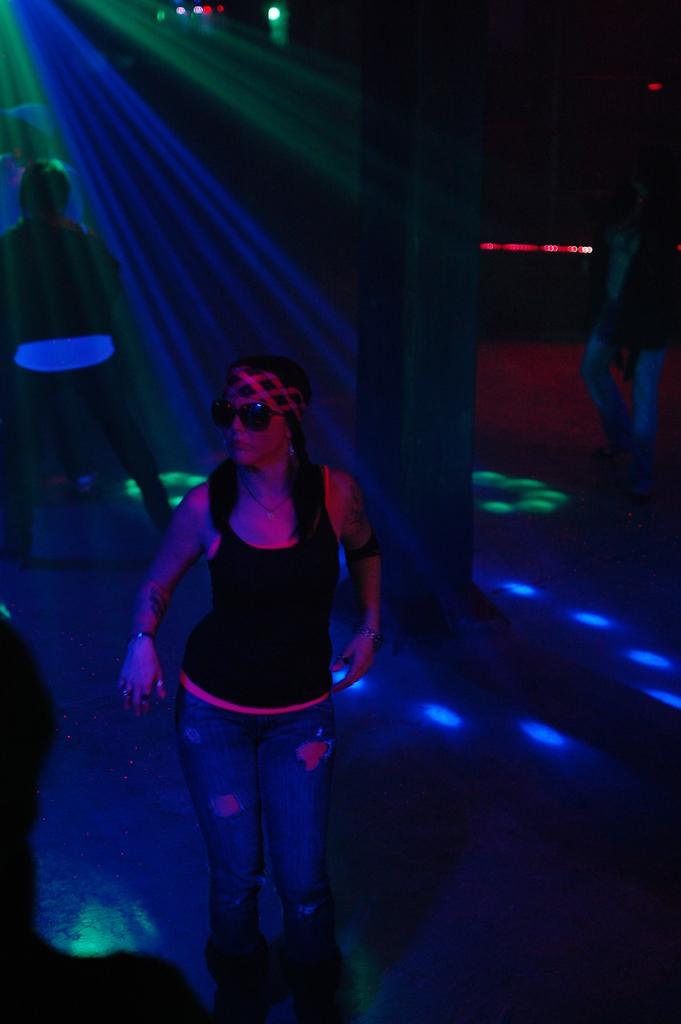What is present in the image? There are people standing in the image. What else can be seen in the image? There are lights visible in the image. What is the distance between the people and the lights in the image? The distance between the people and the lights cannot be determined from the image alone. What type of shoes are the people wearing in the image? The type of shoes the people are wearing cannot be determined from the image alone. What flavor of mint is present in the image? There is no mention of mint in the provided facts, so it cannot be determined if any type of mint is present in the image. 